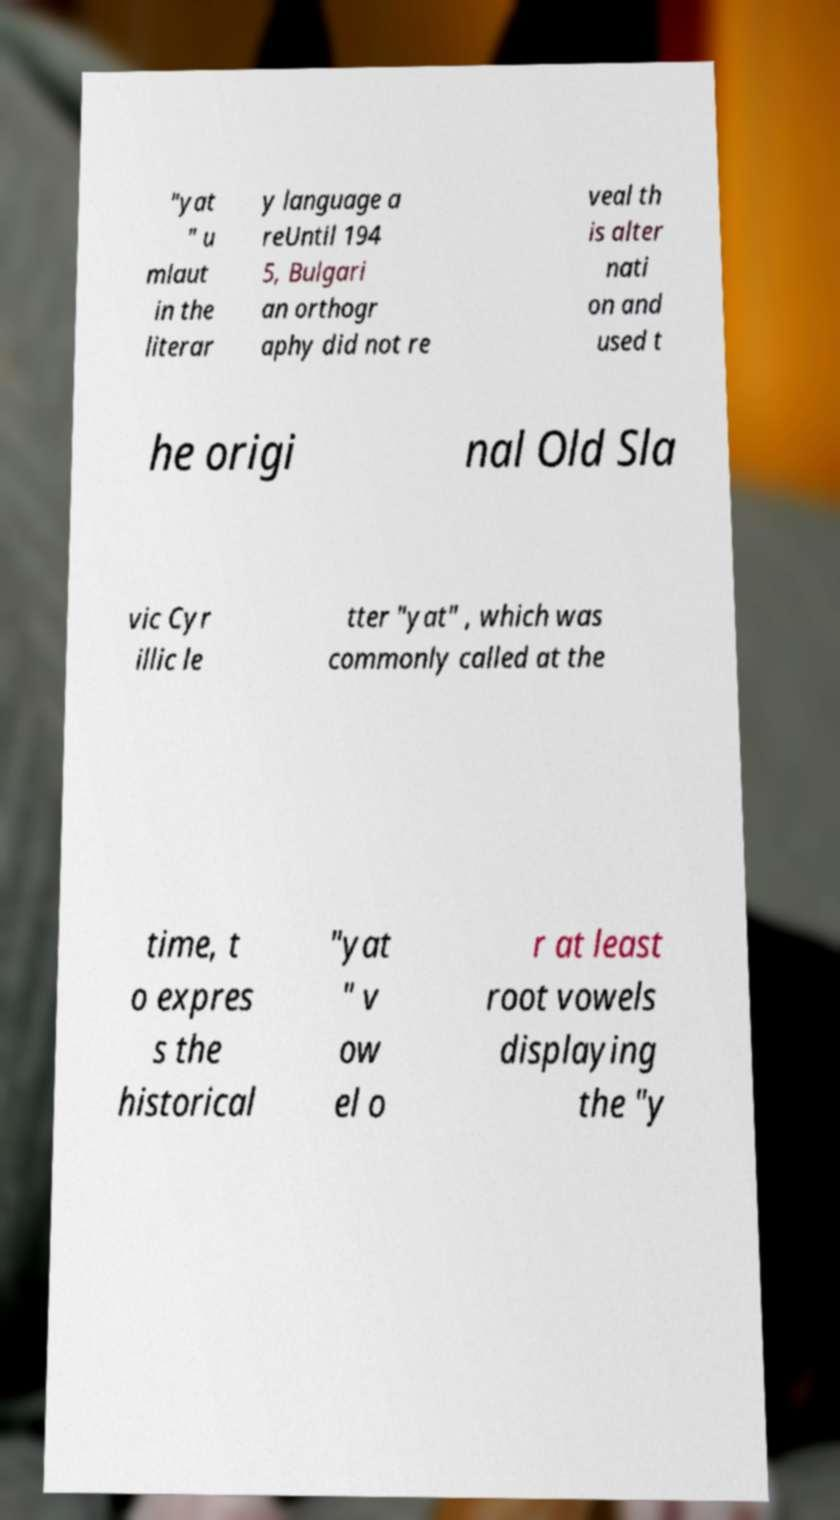Can you accurately transcribe the text from the provided image for me? "yat " u mlaut in the literar y language a reUntil 194 5, Bulgari an orthogr aphy did not re veal th is alter nati on and used t he origi nal Old Sla vic Cyr illic le tter "yat" , which was commonly called at the time, t o expres s the historical "yat " v ow el o r at least root vowels displaying the "y 